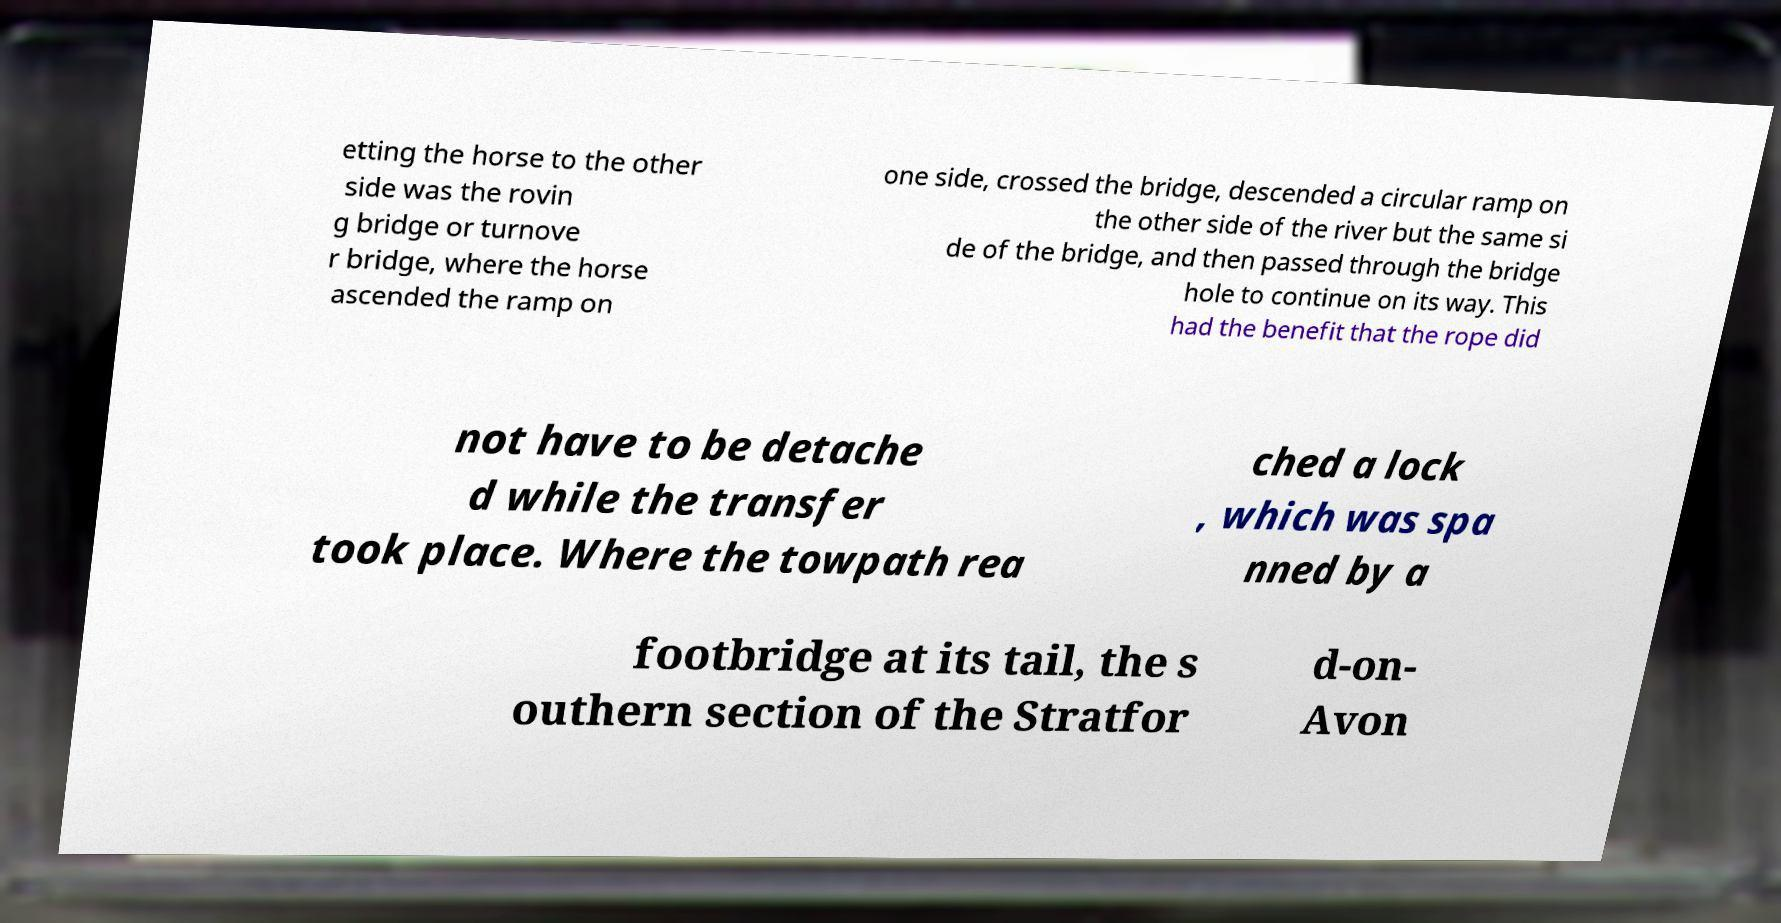Please identify and transcribe the text found in this image. etting the horse to the other side was the rovin g bridge or turnove r bridge, where the horse ascended the ramp on one side, crossed the bridge, descended a circular ramp on the other side of the river but the same si de of the bridge, and then passed through the bridge hole to continue on its way. This had the benefit that the rope did not have to be detache d while the transfer took place. Where the towpath rea ched a lock , which was spa nned by a footbridge at its tail, the s outhern section of the Stratfor d-on- Avon 